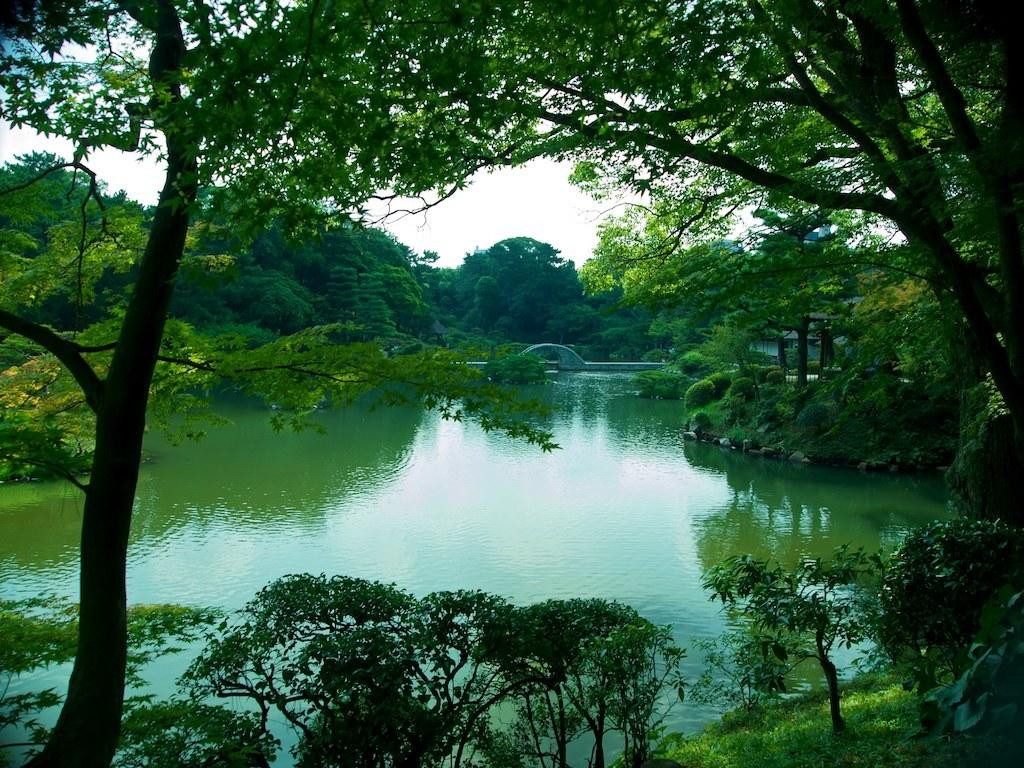What is one of the main elements in the picture? There is water in the picture. What other objects can be seen in the picture? There are stones and trees in the picture. What is visible at the top of the picture? The sky is clear and visible at the top of the picture. Can you see a twig floating on the water in the picture? There is no mention of a twig in the provided facts, so we cannot determine if there is a twig in the image. Are there any socks visible in the picture? There is no mention of socks in the provided facts, so we cannot determine if there are any socks in the image. 